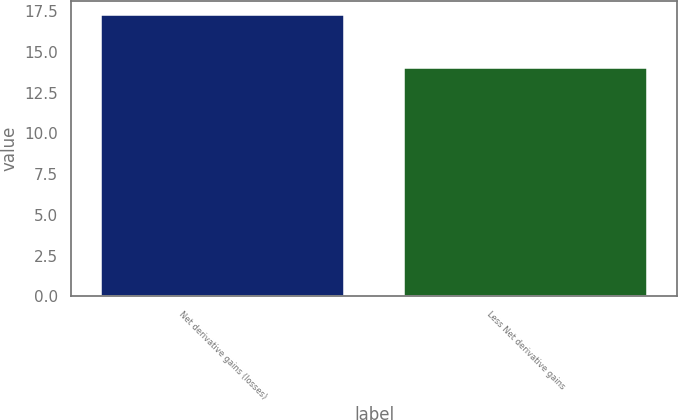Convert chart. <chart><loc_0><loc_0><loc_500><loc_500><bar_chart><fcel>Net derivative gains (losses)<fcel>Less Net derivative gains<nl><fcel>17.3<fcel>14.05<nl></chart> 